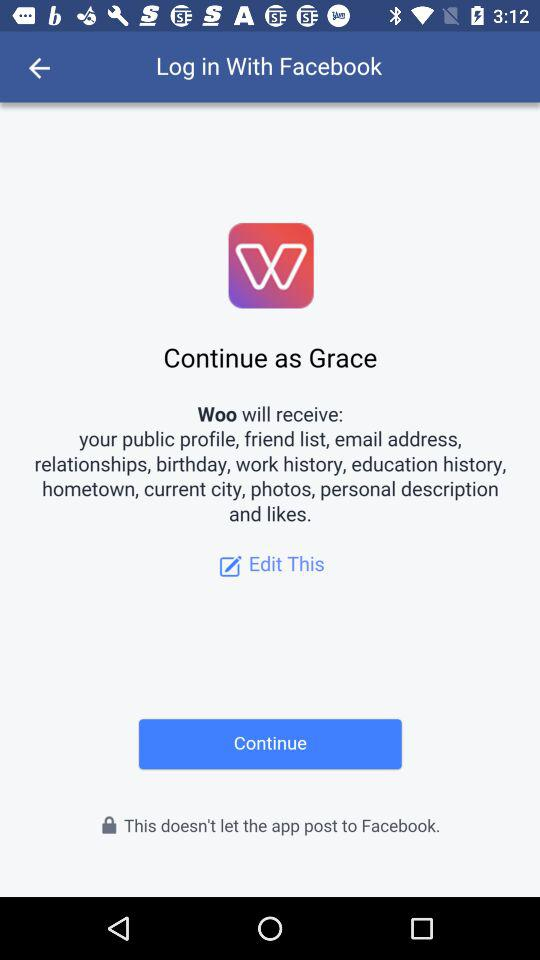Who will receive the public profile, relationships, birthday, current city, photos, and personal information? The application that will receive my public profile, relationships, birthday, current city, photos, and personal information is "Woo". 